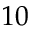<formula> <loc_0><loc_0><loc_500><loc_500>1 0</formula> 